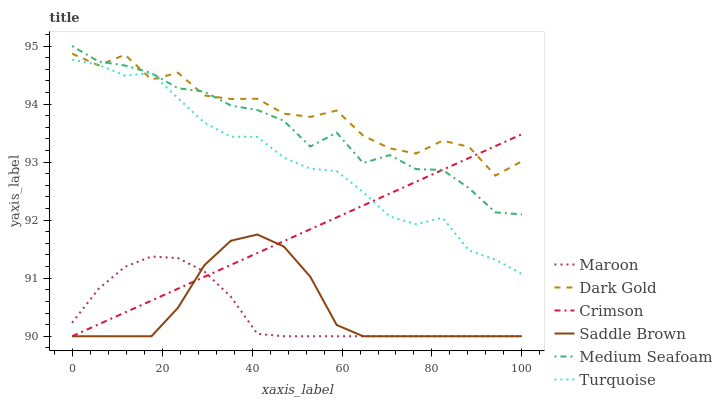Does Maroon have the minimum area under the curve?
Answer yes or no. Yes. Does Dark Gold have the maximum area under the curve?
Answer yes or no. Yes. Does Dark Gold have the minimum area under the curve?
Answer yes or no. No. Does Maroon have the maximum area under the curve?
Answer yes or no. No. Is Crimson the smoothest?
Answer yes or no. Yes. Is Dark Gold the roughest?
Answer yes or no. Yes. Is Maroon the smoothest?
Answer yes or no. No. Is Maroon the roughest?
Answer yes or no. No. Does Maroon have the lowest value?
Answer yes or no. Yes. Does Dark Gold have the lowest value?
Answer yes or no. No. Does Medium Seafoam have the highest value?
Answer yes or no. Yes. Does Dark Gold have the highest value?
Answer yes or no. No. Is Saddle Brown less than Dark Gold?
Answer yes or no. Yes. Is Turquoise greater than Maroon?
Answer yes or no. Yes. Does Dark Gold intersect Crimson?
Answer yes or no. Yes. Is Dark Gold less than Crimson?
Answer yes or no. No. Is Dark Gold greater than Crimson?
Answer yes or no. No. Does Saddle Brown intersect Dark Gold?
Answer yes or no. No. 